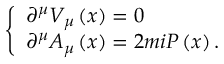Convert formula to latex. <formula><loc_0><loc_0><loc_500><loc_500>\left \{ \begin{array} { l } { { \partial ^ { \mu } V _ { \mu } \left ( x \right ) = 0 } } \\ { { \partial ^ { \mu } A _ { \mu } \left ( x \right ) = 2 m i P \left ( x \right ) . } } \end{array}</formula> 